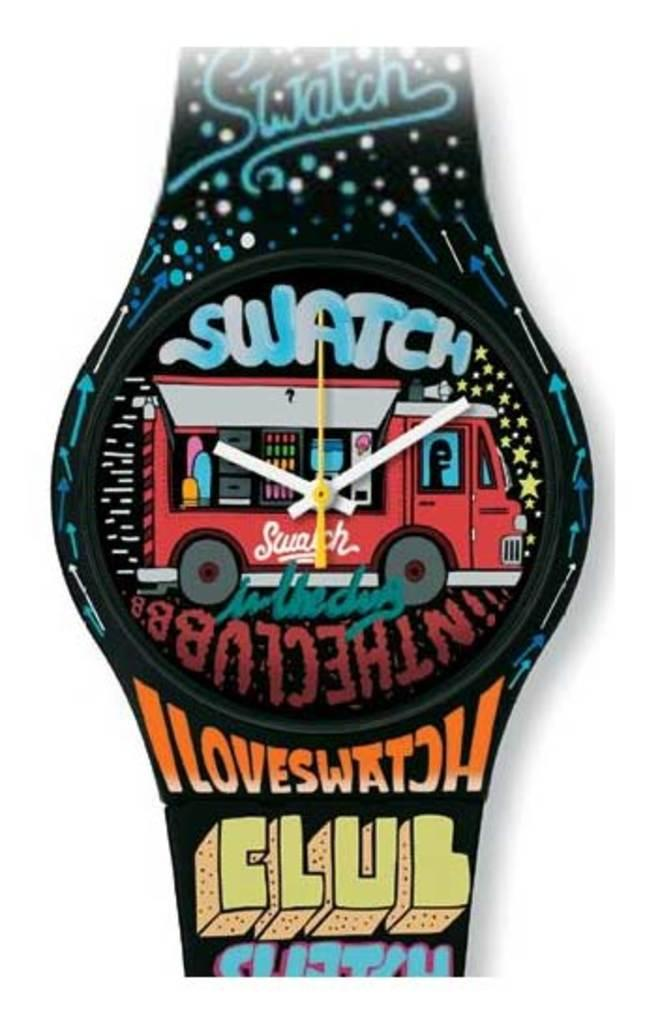Provide a one-sentence caption for the provided image. A picture of a watch that has Swatch on the face along with a food truck while the band says Iloveswatch club. 